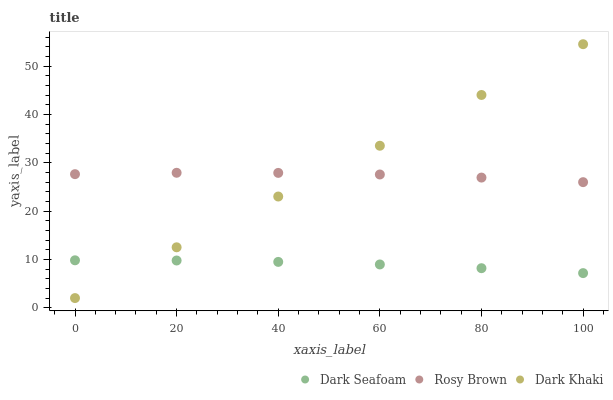Does Dark Seafoam have the minimum area under the curve?
Answer yes or no. Yes. Does Dark Khaki have the maximum area under the curve?
Answer yes or no. Yes. Does Rosy Brown have the minimum area under the curve?
Answer yes or no. No. Does Rosy Brown have the maximum area under the curve?
Answer yes or no. No. Is Dark Khaki the smoothest?
Answer yes or no. Yes. Is Rosy Brown the roughest?
Answer yes or no. Yes. Is Dark Seafoam the smoothest?
Answer yes or no. No. Is Dark Seafoam the roughest?
Answer yes or no. No. Does Dark Khaki have the lowest value?
Answer yes or no. Yes. Does Dark Seafoam have the lowest value?
Answer yes or no. No. Does Dark Khaki have the highest value?
Answer yes or no. Yes. Does Rosy Brown have the highest value?
Answer yes or no. No. Is Dark Seafoam less than Rosy Brown?
Answer yes or no. Yes. Is Rosy Brown greater than Dark Seafoam?
Answer yes or no. Yes. Does Rosy Brown intersect Dark Khaki?
Answer yes or no. Yes. Is Rosy Brown less than Dark Khaki?
Answer yes or no. No. Is Rosy Brown greater than Dark Khaki?
Answer yes or no. No. Does Dark Seafoam intersect Rosy Brown?
Answer yes or no. No. 